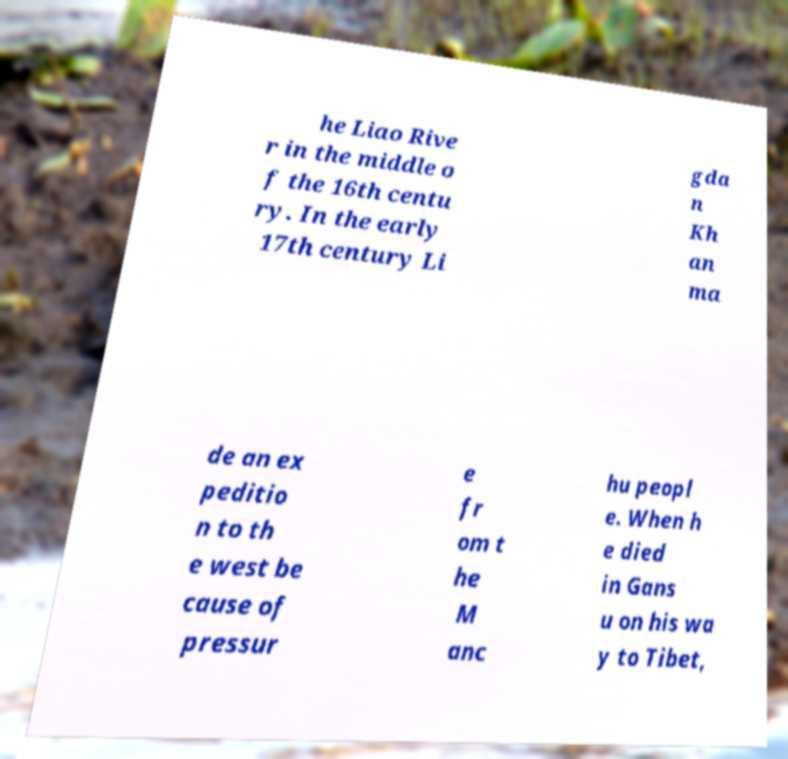I need the written content from this picture converted into text. Can you do that? he Liao Rive r in the middle o f the 16th centu ry. In the early 17th century Li gda n Kh an ma de an ex peditio n to th e west be cause of pressur e fr om t he M anc hu peopl e. When h e died in Gans u on his wa y to Tibet, 